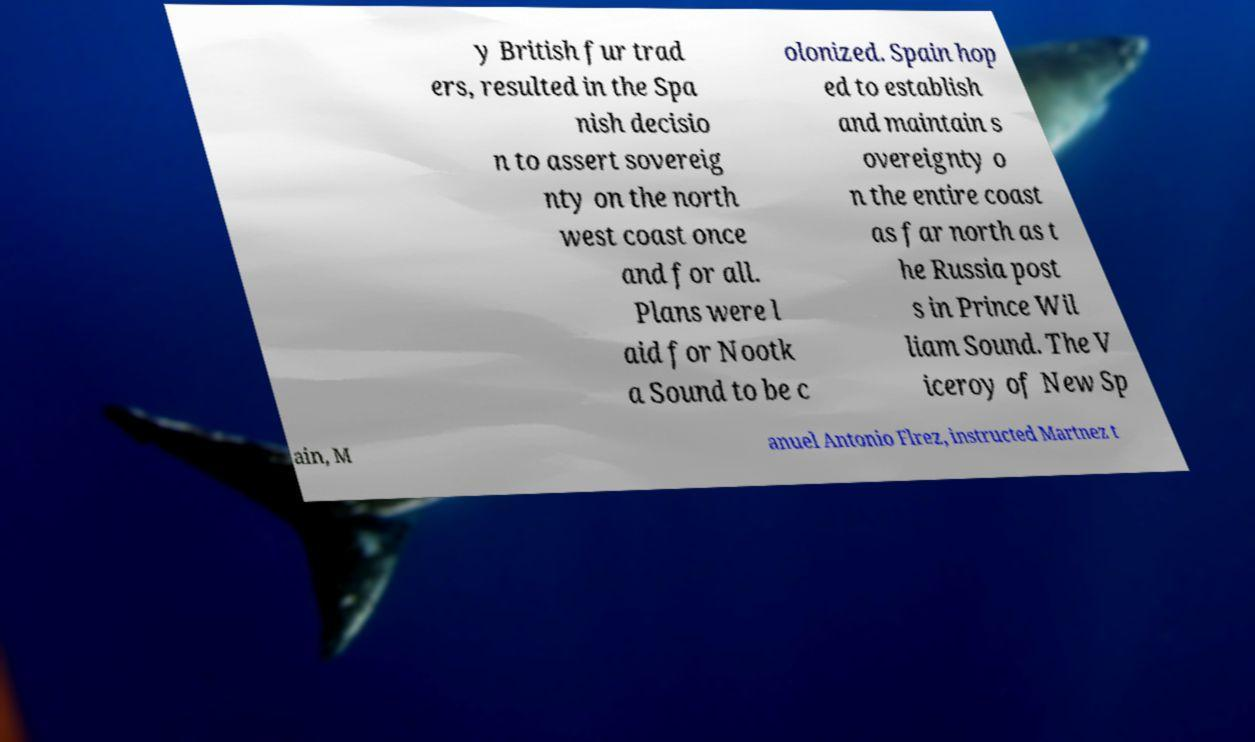There's text embedded in this image that I need extracted. Can you transcribe it verbatim? y British fur trad ers, resulted in the Spa nish decisio n to assert sovereig nty on the north west coast once and for all. Plans were l aid for Nootk a Sound to be c olonized. Spain hop ed to establish and maintain s overeignty o n the entire coast as far north as t he Russia post s in Prince Wil liam Sound. The V iceroy of New Sp ain, M anuel Antonio Flrez, instructed Martnez t 